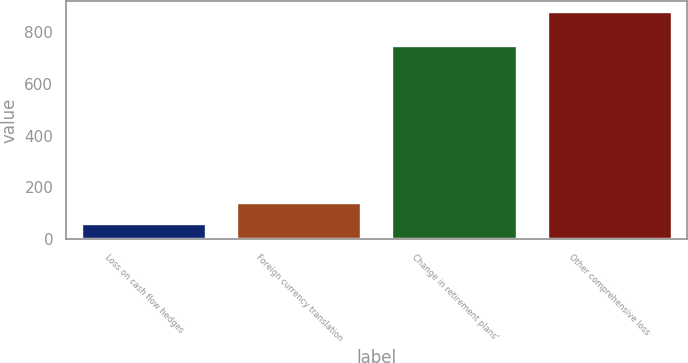<chart> <loc_0><loc_0><loc_500><loc_500><bar_chart><fcel>Loss on cash flow hedges<fcel>Foreign currency translation<fcel>Change in retirement plans'<fcel>Other comprehensive loss<nl><fcel>59<fcel>140.7<fcel>745<fcel>876<nl></chart> 